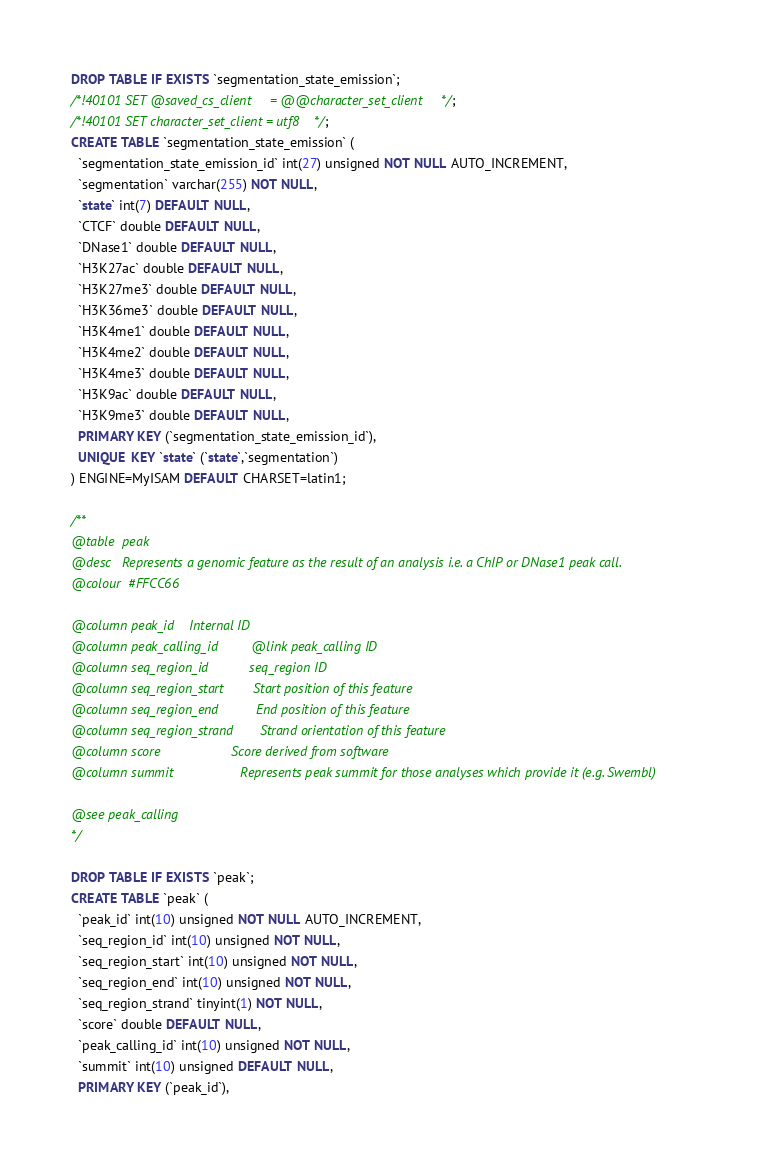Convert code to text. <code><loc_0><loc_0><loc_500><loc_500><_SQL_>DROP TABLE IF EXISTS `segmentation_state_emission`;
/*!40101 SET @saved_cs_client     = @@character_set_client */;
/*!40101 SET character_set_client = utf8 */;
CREATE TABLE `segmentation_state_emission` (
  `segmentation_state_emission_id` int(27) unsigned NOT NULL AUTO_INCREMENT,
  `segmentation` varchar(255) NOT NULL,
  `state` int(7) DEFAULT NULL,
  `CTCF` double DEFAULT NULL,
  `DNase1` double DEFAULT NULL,
  `H3K27ac` double DEFAULT NULL,
  `H3K27me3` double DEFAULT NULL,
  `H3K36me3` double DEFAULT NULL,
  `H3K4me1` double DEFAULT NULL,
  `H3K4me2` double DEFAULT NULL,
  `H3K4me3` double DEFAULT NULL,
  `H3K9ac` double DEFAULT NULL,
  `H3K9me3` double DEFAULT NULL,
  PRIMARY KEY (`segmentation_state_emission_id`),
  UNIQUE KEY `state` (`state`,`segmentation`)
) ENGINE=MyISAM DEFAULT CHARSET=latin1;

/**
@table  peak
@desc   Represents a genomic feature as the result of an analysis i.e. a ChIP or DNase1 peak call.
@colour  #FFCC66

@column peak_id    Internal ID
@column peak_calling_id         @link peak_calling ID
@column seq_region_id           seq_region ID
@column seq_region_start        Start position of this feature
@column seq_region_end          End position of this feature
@column seq_region_strand       Strand orientation of this feature
@column score                   Score derived from software
@column summit                  Represents peak summit for those analyses which provide it (e.g. Swembl)

@see peak_calling
*/

DROP TABLE IF EXISTS `peak`;
CREATE TABLE `peak` (
  `peak_id` int(10) unsigned NOT NULL AUTO_INCREMENT,
  `seq_region_id` int(10) unsigned NOT NULL,
  `seq_region_start` int(10) unsigned NOT NULL,
  `seq_region_end` int(10) unsigned NOT NULL,
  `seq_region_strand` tinyint(1) NOT NULL,
  `score` double DEFAULT NULL,
  `peak_calling_id` int(10) unsigned NOT NULL,
  `summit` int(10) unsigned DEFAULT NULL,
  PRIMARY KEY (`peak_id`),</code> 